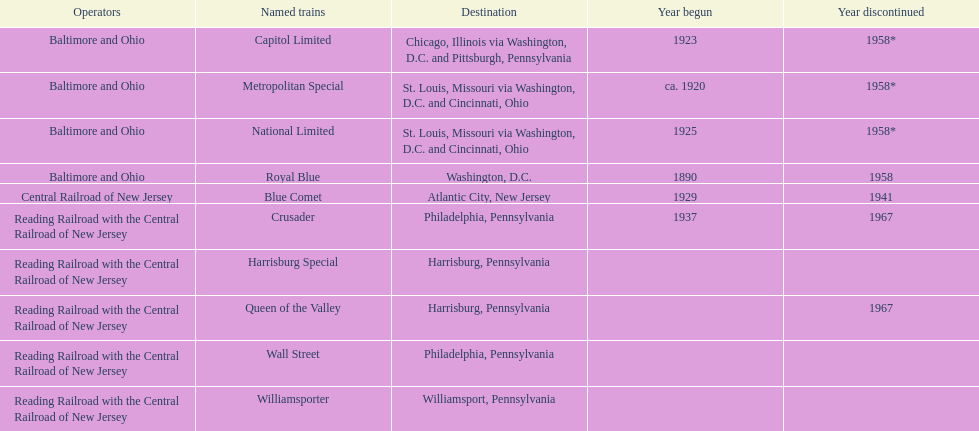How many years have started in total? 6. 